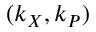Convert formula to latex. <formula><loc_0><loc_0><loc_500><loc_500>( k _ { X } , k _ { P } )</formula> 